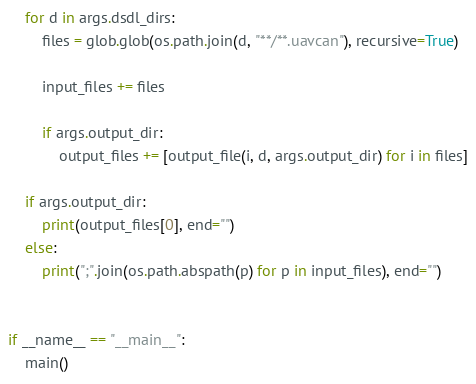Convert code to text. <code><loc_0><loc_0><loc_500><loc_500><_Python_>    for d in args.dsdl_dirs:
        files = glob.glob(os.path.join(d, "**/**.uavcan"), recursive=True)

        input_files += files

        if args.output_dir:
            output_files += [output_file(i, d, args.output_dir) for i in files]

    if args.output_dir:
        print(output_files[0], end="")
    else:
        print(";".join(os.path.abspath(p) for p in input_files), end="")


if __name__ == "__main__":
    main()
</code> 